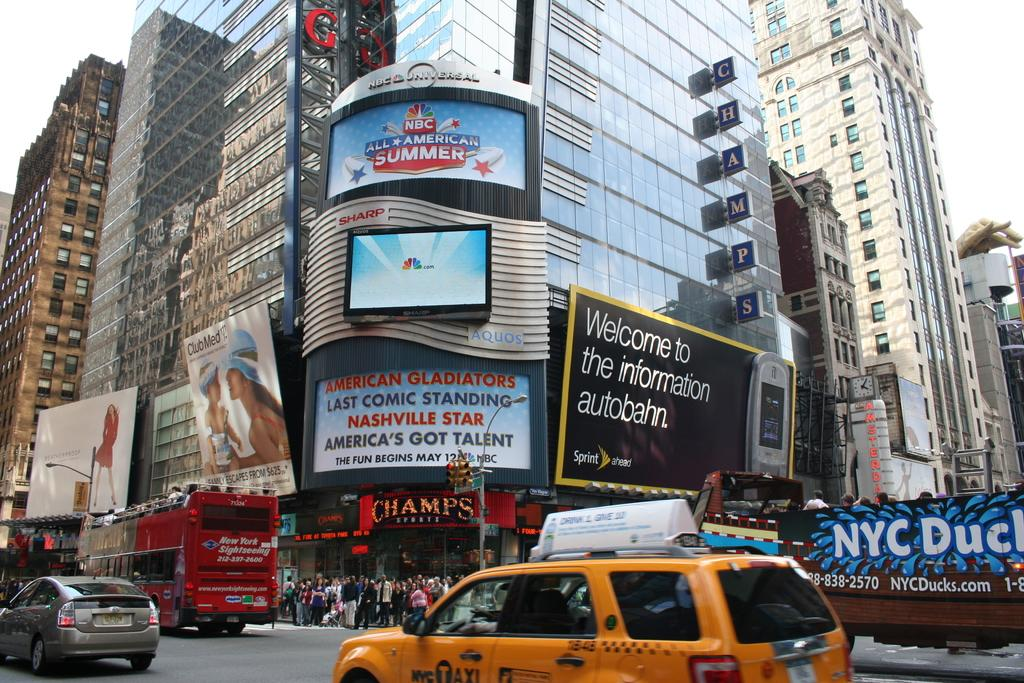Provide a one-sentence caption for the provided image. In a crowded city neighborhood, a Sprint billboard refers to the Information Autobahn. 